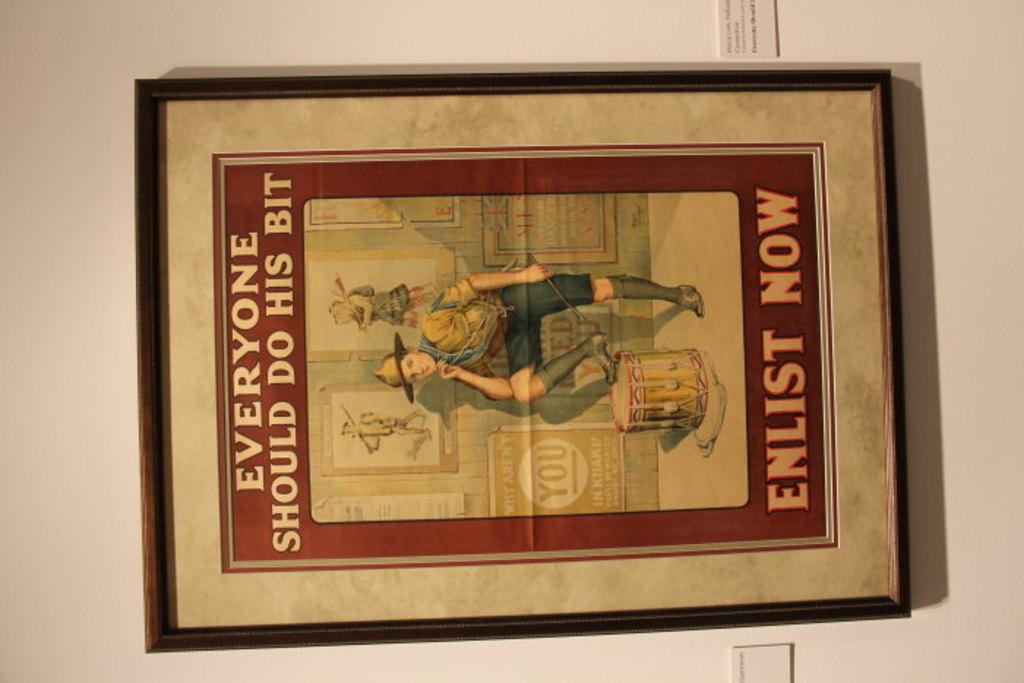Who should do the bit?
Your answer should be very brief. Everyone. What should you do now?
Provide a short and direct response. Enlist. 